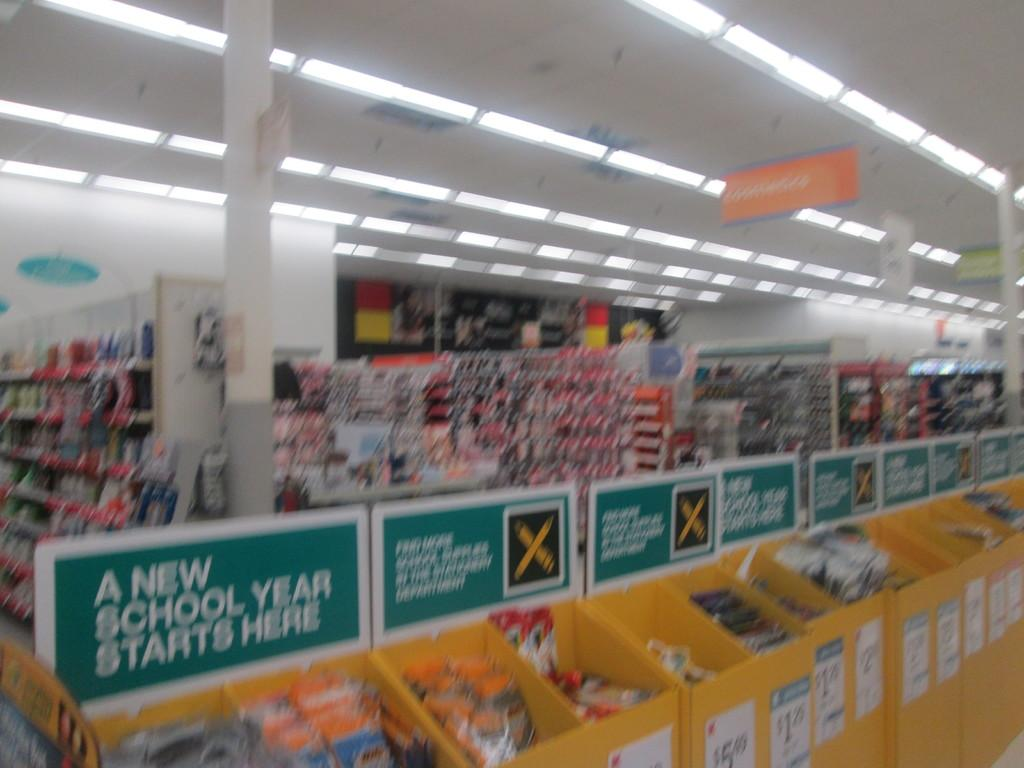<image>
Provide a brief description of the given image. the inside of a store with bins in the middle with signs above it that say 'a new school year starts here' 